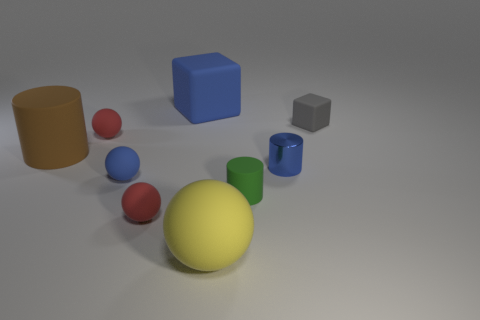Subtract 1 spheres. How many spheres are left? 3 Add 1 big yellow metallic things. How many objects exist? 10 Subtract all cylinders. How many objects are left? 6 Add 2 blue rubber cylinders. How many blue rubber cylinders exist? 2 Subtract 0 yellow cubes. How many objects are left? 9 Subtract all matte cylinders. Subtract all brown matte cylinders. How many objects are left? 6 Add 8 green matte cylinders. How many green matte cylinders are left? 9 